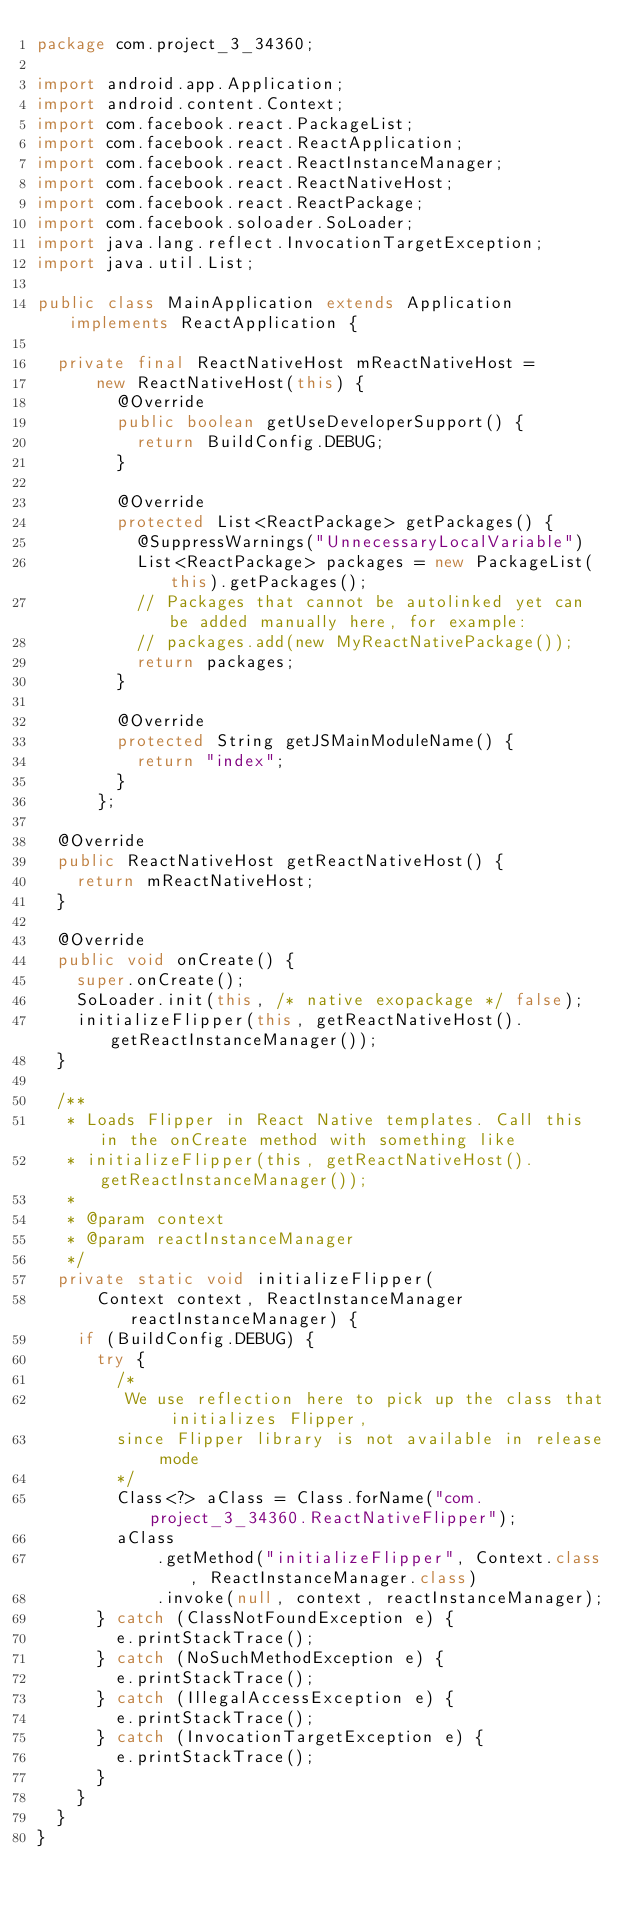Convert code to text. <code><loc_0><loc_0><loc_500><loc_500><_Java_>package com.project_3_34360;

import android.app.Application;
import android.content.Context;
import com.facebook.react.PackageList;
import com.facebook.react.ReactApplication;
import com.facebook.react.ReactInstanceManager;
import com.facebook.react.ReactNativeHost;
import com.facebook.react.ReactPackage;
import com.facebook.soloader.SoLoader;
import java.lang.reflect.InvocationTargetException;
import java.util.List;

public class MainApplication extends Application implements ReactApplication {

  private final ReactNativeHost mReactNativeHost =
      new ReactNativeHost(this) {
        @Override
        public boolean getUseDeveloperSupport() {
          return BuildConfig.DEBUG;
        }

        @Override
        protected List<ReactPackage> getPackages() {
          @SuppressWarnings("UnnecessaryLocalVariable")
          List<ReactPackage> packages = new PackageList(this).getPackages();
          // Packages that cannot be autolinked yet can be added manually here, for example:
          // packages.add(new MyReactNativePackage());
          return packages;
        }

        @Override
        protected String getJSMainModuleName() {
          return "index";
        }
      };

  @Override
  public ReactNativeHost getReactNativeHost() {
    return mReactNativeHost;
  }

  @Override
  public void onCreate() {
    super.onCreate();
    SoLoader.init(this, /* native exopackage */ false);
    initializeFlipper(this, getReactNativeHost().getReactInstanceManager());
  }

  /**
   * Loads Flipper in React Native templates. Call this in the onCreate method with something like
   * initializeFlipper(this, getReactNativeHost().getReactInstanceManager());
   *
   * @param context
   * @param reactInstanceManager
   */
  private static void initializeFlipper(
      Context context, ReactInstanceManager reactInstanceManager) {
    if (BuildConfig.DEBUG) {
      try {
        /*
         We use reflection here to pick up the class that initializes Flipper,
        since Flipper library is not available in release mode
        */
        Class<?> aClass = Class.forName("com.project_3_34360.ReactNativeFlipper");
        aClass
            .getMethod("initializeFlipper", Context.class, ReactInstanceManager.class)
            .invoke(null, context, reactInstanceManager);
      } catch (ClassNotFoundException e) {
        e.printStackTrace();
      } catch (NoSuchMethodException e) {
        e.printStackTrace();
      } catch (IllegalAccessException e) {
        e.printStackTrace();
      } catch (InvocationTargetException e) {
        e.printStackTrace();
      }
    }
  }
}
</code> 